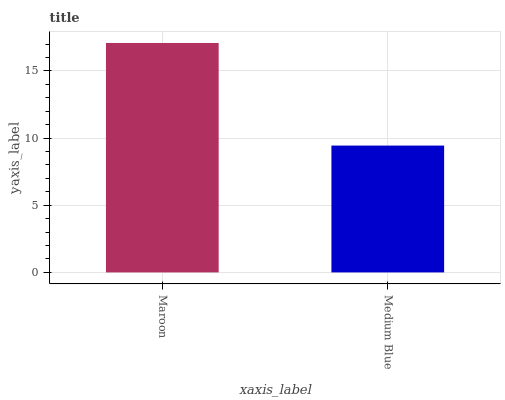Is Medium Blue the minimum?
Answer yes or no. Yes. Is Maroon the maximum?
Answer yes or no. Yes. Is Medium Blue the maximum?
Answer yes or no. No. Is Maroon greater than Medium Blue?
Answer yes or no. Yes. Is Medium Blue less than Maroon?
Answer yes or no. Yes. Is Medium Blue greater than Maroon?
Answer yes or no. No. Is Maroon less than Medium Blue?
Answer yes or no. No. Is Maroon the high median?
Answer yes or no. Yes. Is Medium Blue the low median?
Answer yes or no. Yes. Is Medium Blue the high median?
Answer yes or no. No. Is Maroon the low median?
Answer yes or no. No. 